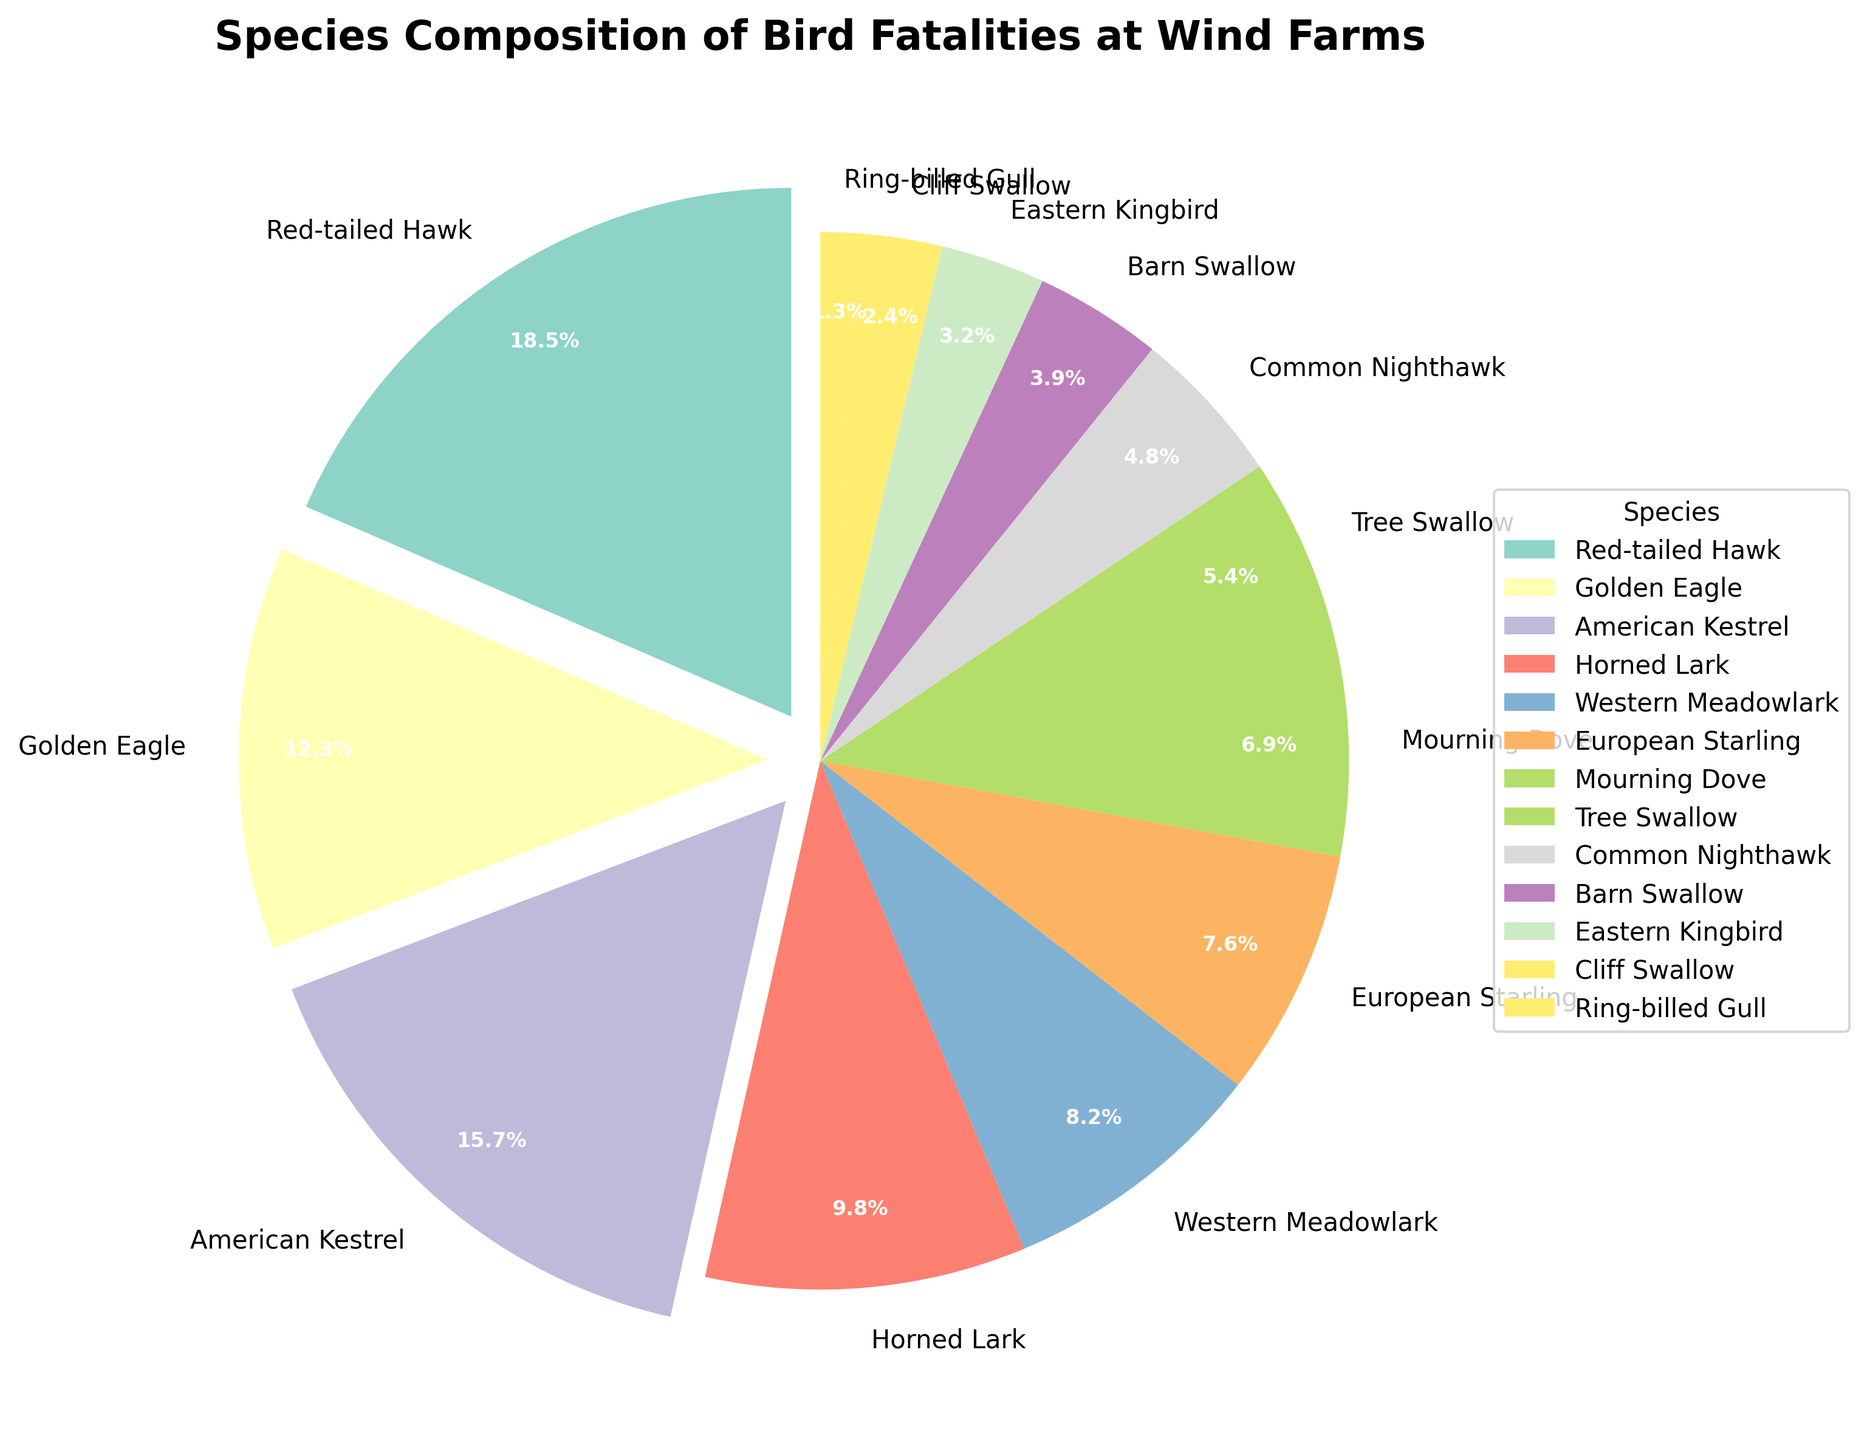Which species has the highest percentage of fatalities? To determine which species has the highest percentage of fatalities, look at the slices of the pie chart and locate the one with the largest size or the highest percentage label.
Answer: Red-tailed Hawk What is the combined percentage of fatalities for Red-tailed Hawk and Golden Eagle? Sum the percentages for Red-tailed Hawk (18.5%) and Golden Eagle (12.3%): 18.5 + 12.3.
Answer: 30.8% How many species have a fatality percentage greater than 10%? Identify each slice of the pie chart with a percentage label greater than 10%: Red-tailed Hawk, Golden Eagle, and American Kestrel are the only ones with percentages above 10%.
Answer: 3 Which species has a smaller percentage of fatalities, European Starling or Mourning Dove? Compare the percentages for European Starling (7.6%) and Mourning Dove (6.9%) to determine which is smaller.
Answer: Mourning Dove What is the difference in percentage between American Kestrel and Horned Lark fatalities? Subtract the percentage of Horned Lark (9.8%) from the percentage of American Kestrel (15.7%): 15.7 - 9.8.
Answer: 5.9% Which species are represented with colors that are visually distinguishable, and what are their colors? Identify the different colors used in the pie chart slices to distinguish each species. Since these colors are based on a colorblind-friendly palette, each species slice can be visually distinguished, though the exact colors should be described generically as there are no exact hues in the description. List any three distinguishable species and their colors.
Answer: Example: Red-tailed Hawk (peach), Golden Eagle (blue), American Kestrel (orange) Are there more species with fatality percentages above or below 5%? Count the number of species with percentages above 5% and those with percentages below 5% to compare. Above 5% are: Red-tailed Hawk, Golden Eagle, American Kestrel, Horned Lark, Western Meadowlark, European Starling, and Mourning Dove. Below 5% are: Tree Swallow, Common Nighthawk, Barn Swallow, Eastern Kingbird, Cliff Swallow, and Ring-billed Gull.
Answer: Equal (7 each) What is the average percentage of the species with the three smallest proportions? Identify the three smallest percentages: Ring-billed Gull (1.3%), Cliff Swallow (2.4%), and Eastern Kingbird (3.2%). Calculate the average by summing these values and dividing by 3: (1.3 + 2.4 + 3.2) / 3.
Answer: 2.3% Which species has its slice exploded (separated) from the rest of the pie chart? Look for the slice that appears slightly detached from the main pie chart, which indicates it has been "exploded" to emphasize its importance.
Answer: Red-tailed Hawk 